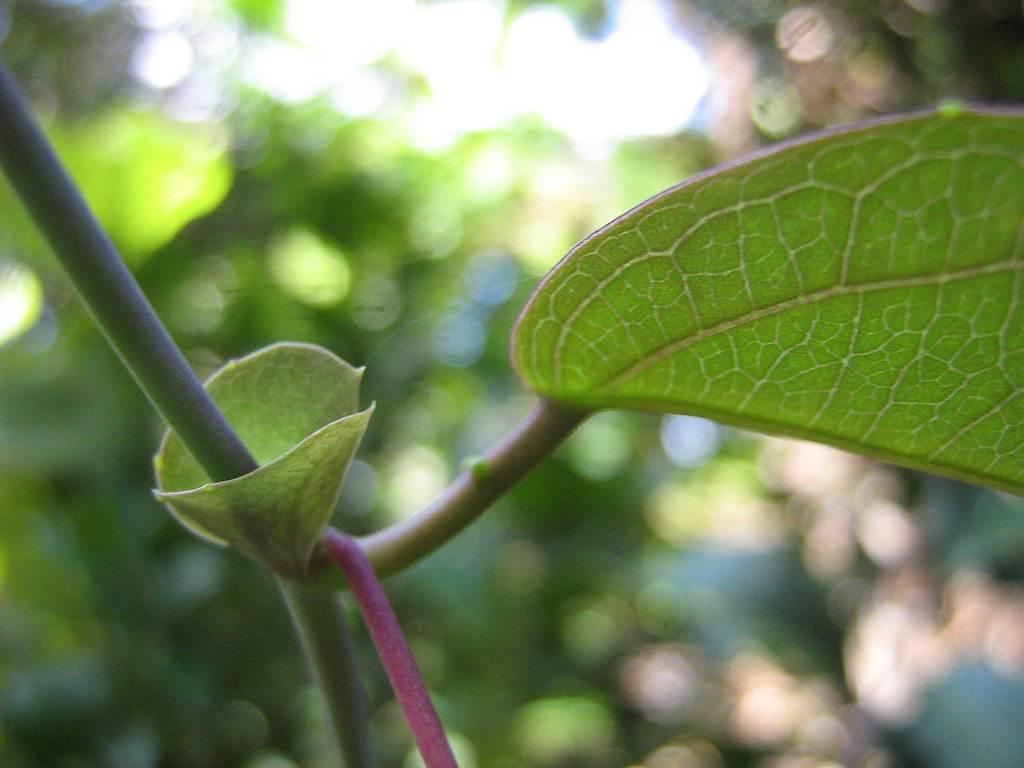What is visible in the foreground of the image? There are leaves and a stem in the foreground of the image. What can be observed about the background of the image? The background of the image is blurred. What type of industry is depicted in the image? There is no industry present in the image; it primarily features leaves and a stem in the foreground. What kind of organization is responsible for the arrangement of the leaves in the image? There is no organization responsible for the arrangement of the leaves in the image; they are a natural occurrence. 